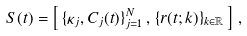Convert formula to latex. <formula><loc_0><loc_0><loc_500><loc_500>S ( t ) = \left [ \, \{ \kappa _ { j } , C _ { j } ( t ) \} _ { j = 1 } ^ { N } \, , \, \{ r ( t ; k ) \} _ { k \in { \mathbb { R } } } \, \right ] \, ,</formula> 